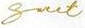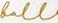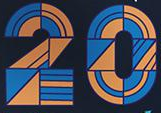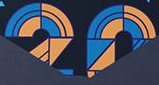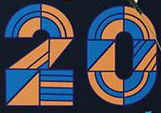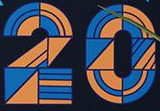Transcribe the words shown in these images in order, separated by a semicolon. Snet; foll; 20; 20; 20; 20 